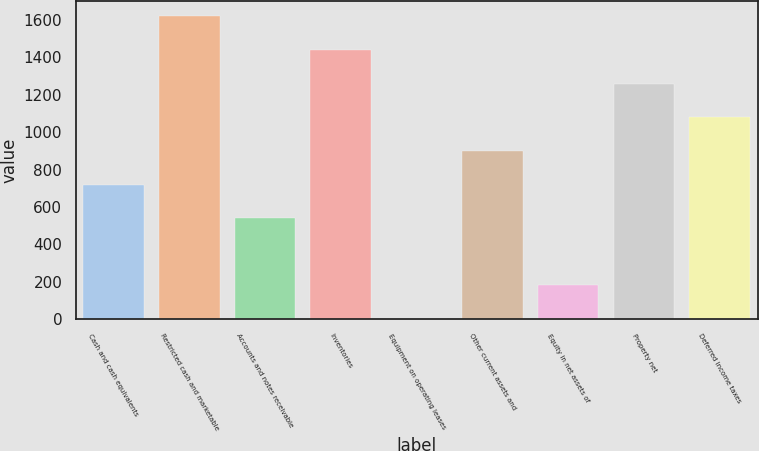Convert chart. <chart><loc_0><loc_0><loc_500><loc_500><bar_chart><fcel>Cash and cash equivalents<fcel>Restricted cash and marketable<fcel>Accounts and notes receivable<fcel>Inventories<fcel>Equipment on operating leases<fcel>Other current assets and<fcel>Equity in net assets of<fcel>Property net<fcel>Deferred income taxes<nl><fcel>720<fcel>1617.5<fcel>540.5<fcel>1438<fcel>2<fcel>899.5<fcel>181.5<fcel>1258.5<fcel>1079<nl></chart> 